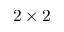<formula> <loc_0><loc_0><loc_500><loc_500>2 \times 2</formula> 